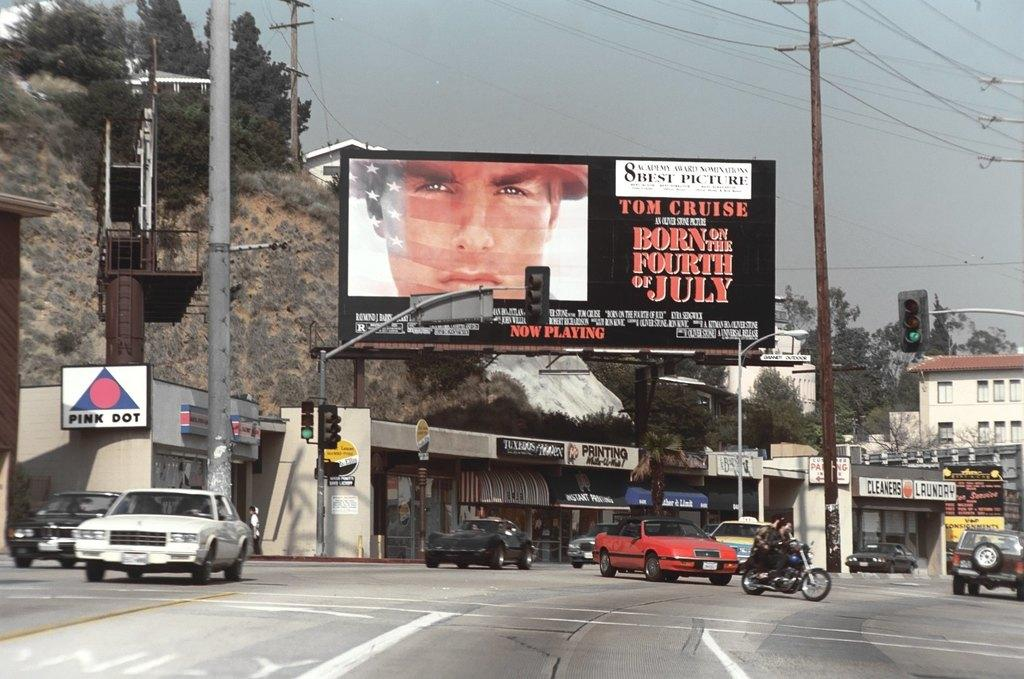<image>
Share a concise interpretation of the image provided. a Born on the Fourth of July on the sign 